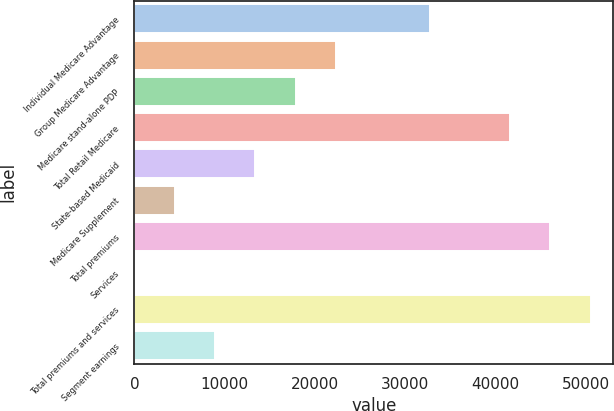Convert chart to OTSL. <chart><loc_0><loc_0><loc_500><loc_500><bar_chart><fcel>Individual Medicare Advantage<fcel>Group Medicare Advantage<fcel>Medicare stand-alone PDP<fcel>Total Retail Medicare<fcel>State-based Medicaid<fcel>Medicare Supplement<fcel>Total premiums<fcel>Services<fcel>Total premiums and services<fcel>Segment earnings<nl><fcel>32720<fcel>22323<fcel>17860.4<fcel>41577<fcel>13397.8<fcel>4472.6<fcel>46039.6<fcel>10<fcel>50502.2<fcel>8935.2<nl></chart> 